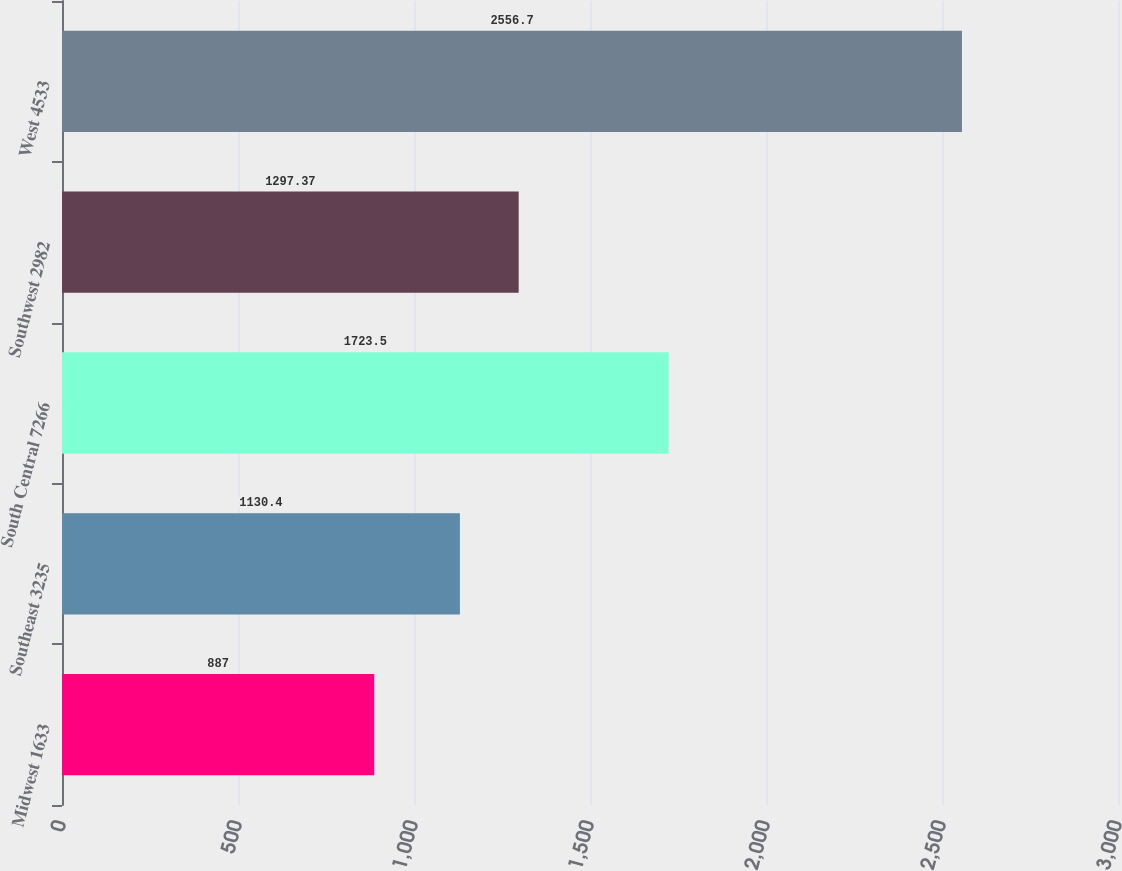Convert chart. <chart><loc_0><loc_0><loc_500><loc_500><bar_chart><fcel>Midwest 1633<fcel>Southeast 3235<fcel>South Central 7266<fcel>Southwest 2982<fcel>West 4533<nl><fcel>887<fcel>1130.4<fcel>1723.5<fcel>1297.37<fcel>2556.7<nl></chart> 